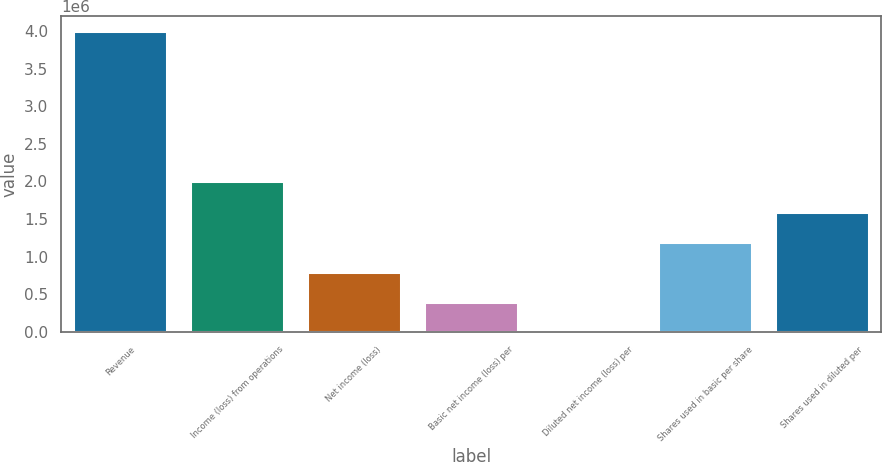Convert chart. <chart><loc_0><loc_0><loc_500><loc_500><bar_chart><fcel>Revenue<fcel>Income (loss) from operations<fcel>Net income (loss)<fcel>Basic net income (loss) per<fcel>Diluted net income (loss) per<fcel>Shares used in basic per share<fcel>Shares used in diluted per<nl><fcel>3.99793e+06<fcel>1.99897e+06<fcel>799587<fcel>399794<fcel>0.94<fcel>1.19938e+06<fcel>1.59917e+06<nl></chart> 